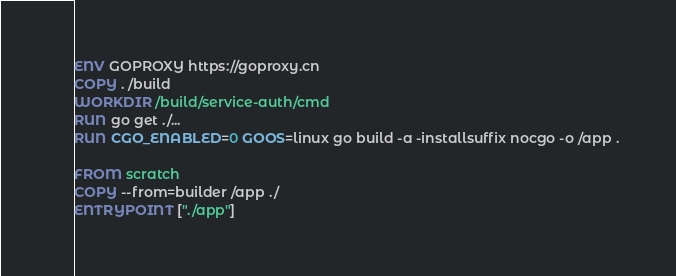Convert code to text. <code><loc_0><loc_0><loc_500><loc_500><_Dockerfile_>ENV GOPROXY https://goproxy.cn
COPY . /build
WORKDIR /build/service-auth/cmd
RUN go get ./...
RUN CGO_ENABLED=0 GOOS=linux go build -a -installsuffix nocgo -o /app .

FROM scratch
COPY --from=builder /app ./
ENTRYPOINT ["./app"]</code> 